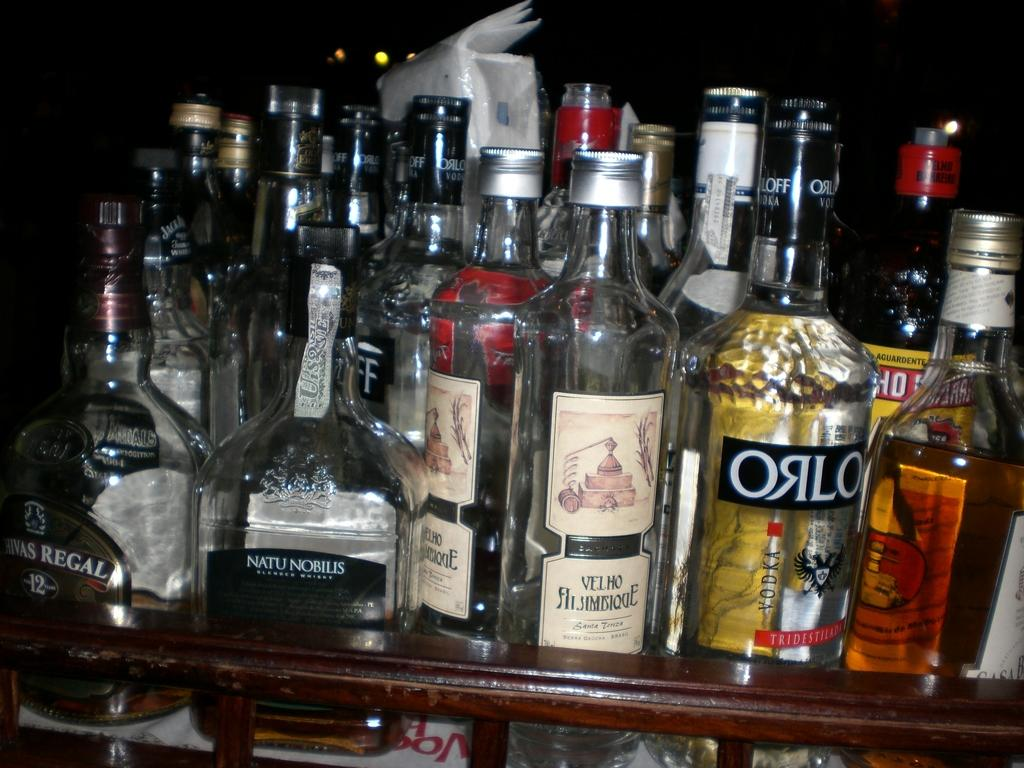<image>
Provide a brief description of the given image. shelf of alcohol including natu nobilis, velho, and orlo among others 